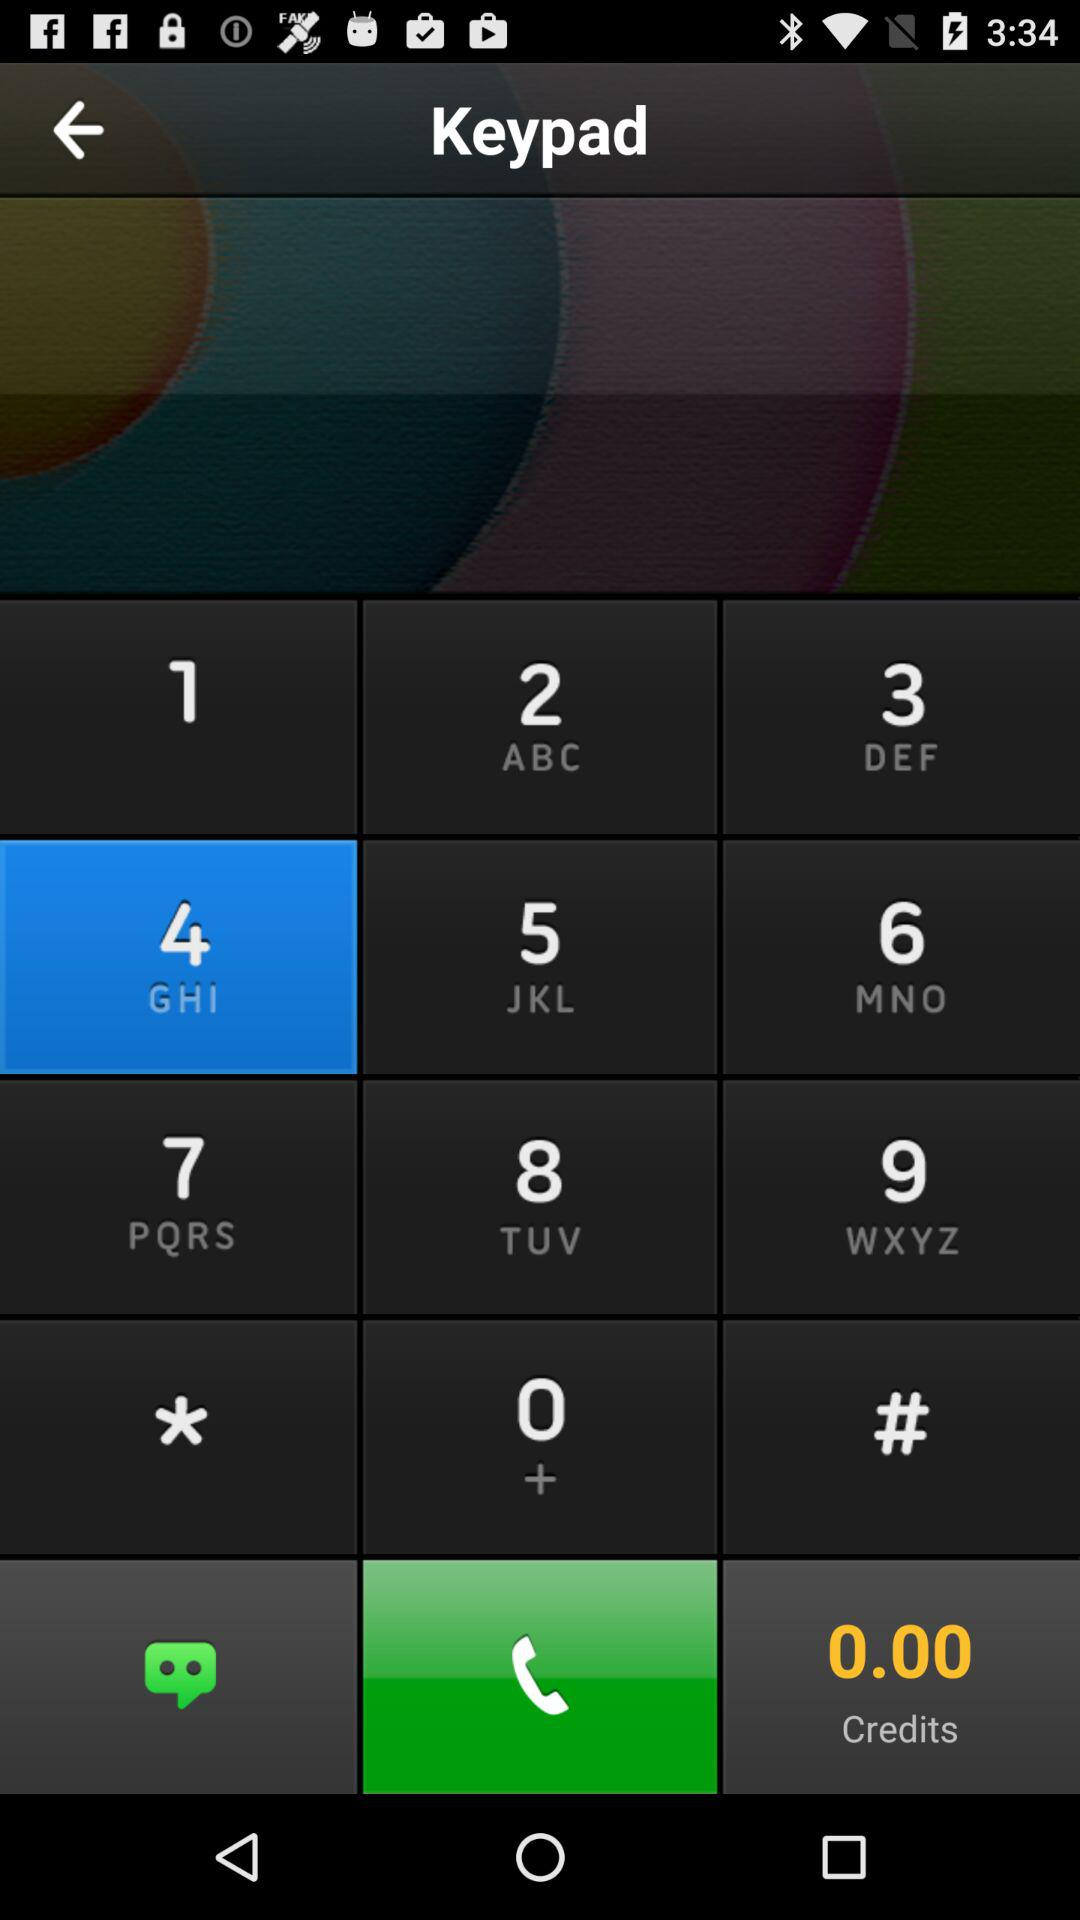How many credits are there? There are 0 credits. 